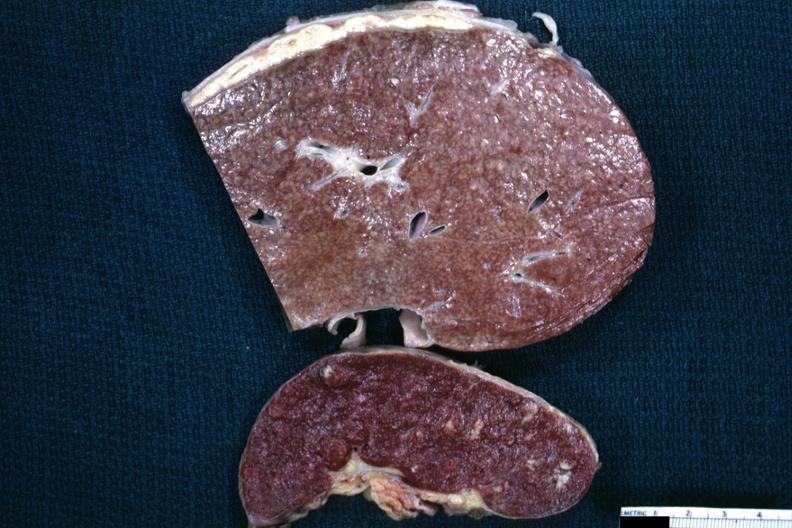s peritoneum present?
Answer the question using a single word or phrase. Yes 